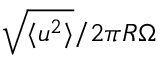Convert formula to latex. <formula><loc_0><loc_0><loc_500><loc_500>\sqrt { \langle u ^ { 2 } \rangle } / 2 \pi R \Omega</formula> 